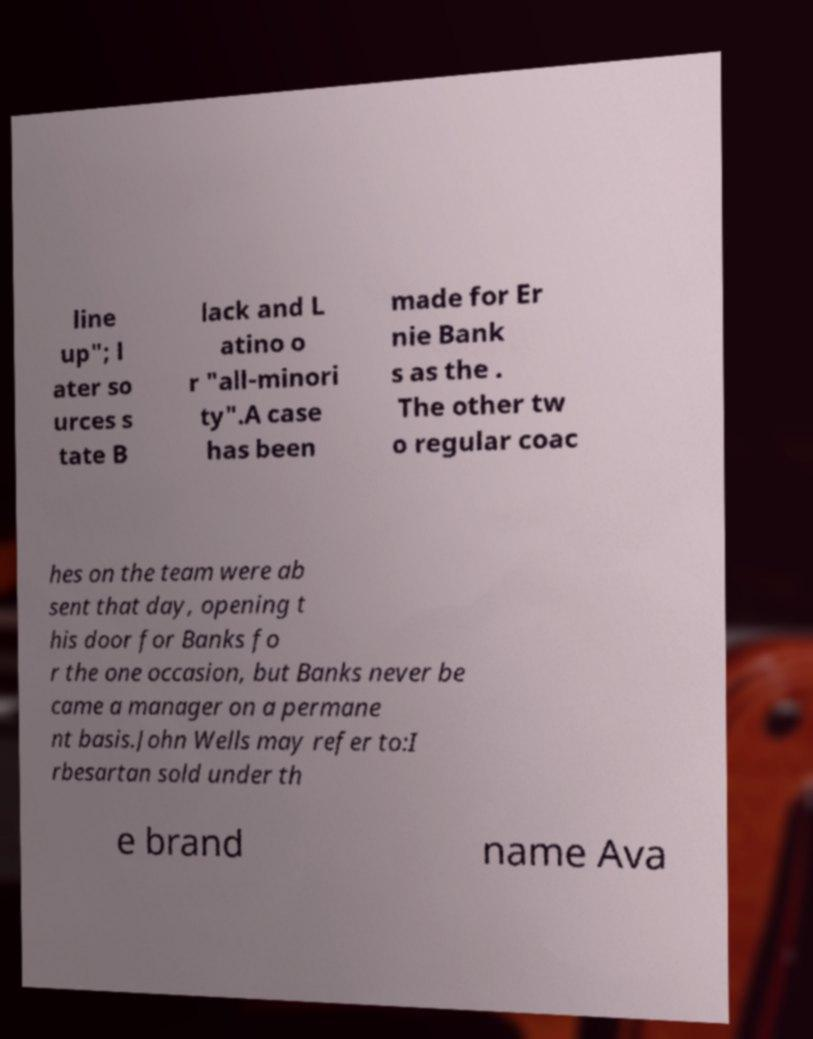Can you accurately transcribe the text from the provided image for me? line up"; l ater so urces s tate B lack and L atino o r "all-minori ty".A case has been made for Er nie Bank s as the . The other tw o regular coac hes on the team were ab sent that day, opening t his door for Banks fo r the one occasion, but Banks never be came a manager on a permane nt basis.John Wells may refer to:I rbesartan sold under th e brand name Ava 